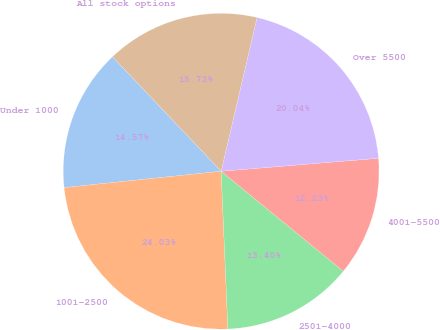<chart> <loc_0><loc_0><loc_500><loc_500><pie_chart><fcel>Under 1000<fcel>1001-2500<fcel>2501-4000<fcel>4001-5500<fcel>Over 5500<fcel>All stock options<nl><fcel>14.57%<fcel>24.03%<fcel>13.4%<fcel>12.23%<fcel>20.04%<fcel>15.73%<nl></chart> 